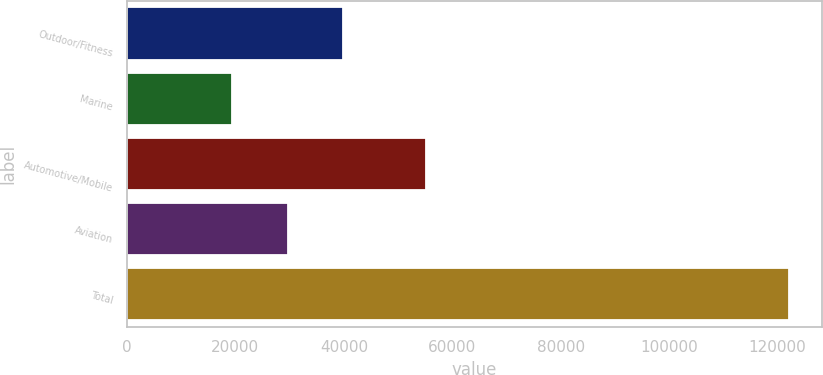Convert chart. <chart><loc_0><loc_0><loc_500><loc_500><bar_chart><fcel>Outdoor/Fitness<fcel>Marine<fcel>Automotive/Mobile<fcel>Aviation<fcel>Total<nl><fcel>39909.8<fcel>19382<fcel>55125<fcel>29645.9<fcel>122021<nl></chart> 